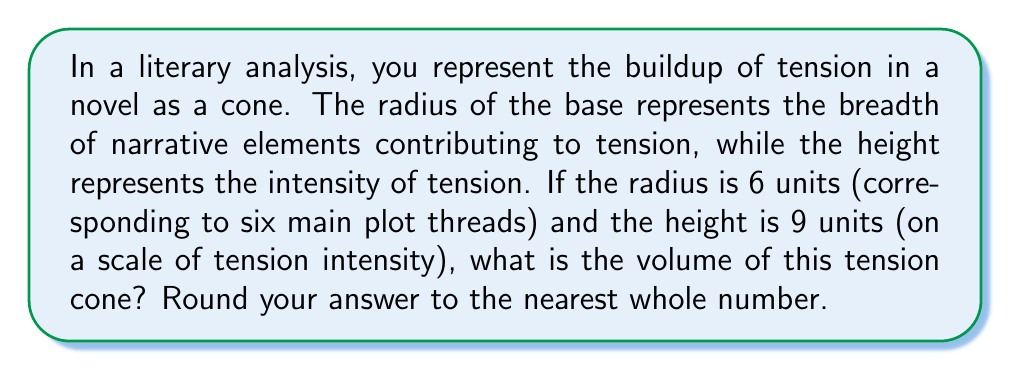Can you solve this math problem? Let's approach this step-by-step:

1) The formula for the volume of a cone is:

   $$V = \frac{1}{3}\pi r^2 h$$

   Where $r$ is the radius of the base and $h$ is the height.

2) We are given:
   $r = 6$ units
   $h = 9$ units

3) Let's substitute these values into our formula:

   $$V = \frac{1}{3}\pi (6)^2 (9)$$

4) Simplify the exponent:
   
   $$V = \frac{1}{3}\pi (36) (9)$$

5) Multiply the numbers:

   $$V = 108\pi$$

6) Calculate this value (using 3.14159 for $\pi$):

   $$V = 108 * 3.14159 \approx 339.29172$$

7) Rounding to the nearest whole number:

   $$V \approx 339$$

This volume represents the total buildup of tension in the narrative, combining the breadth of contributing elements (radius) with the intensity of the tension (height).
Answer: 339 cubic units 